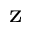<formula> <loc_0><loc_0><loc_500><loc_500>^ { z }</formula> 